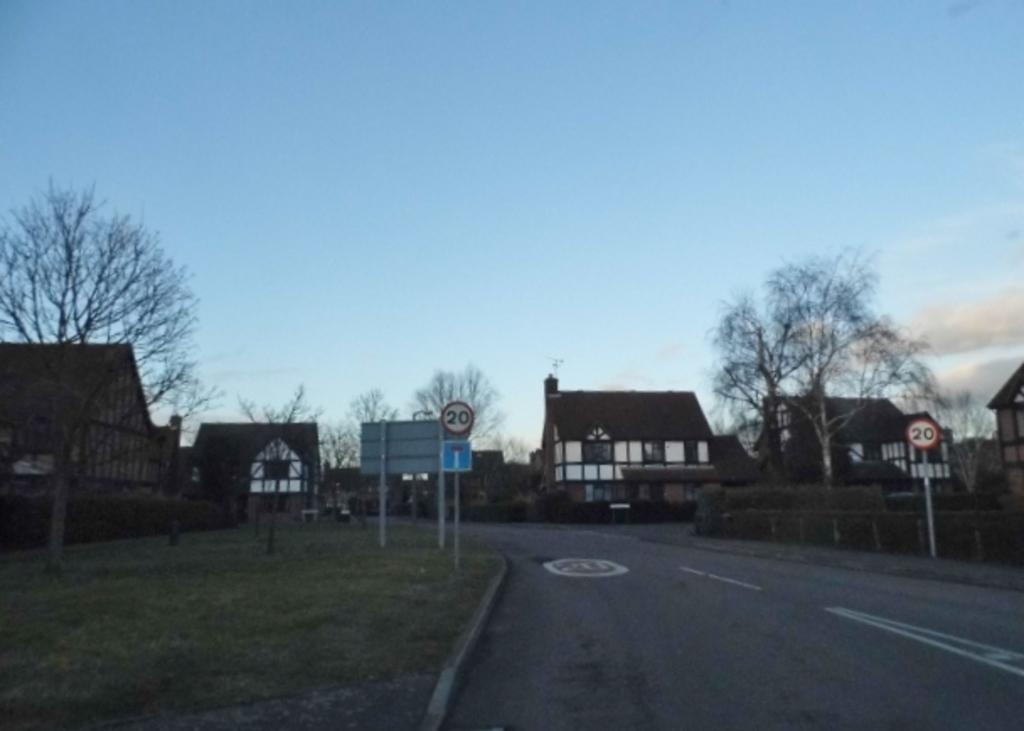What type of structures can be seen in the image? There are houses in the image. What type of vegetation is present in the image? There are trees in the image. What type of information might be conveyed by the sign boards in the image? The sign boards in the image might convey information about directions, advertisements, or warnings. What type of ground surface is visible in the image? There is grass visible in the image. What part of the natural environment is visible in the image? The sky is visible in the image. What type of company is being discussed in the image? There is no company being discussed in the image; it features houses, trees, sign boards, grass, and the sky. What part of the image is made of a specific material, such as metal or wood? The provided facts do not specify the material of any part of the image, so it cannot be determined from the information given. 